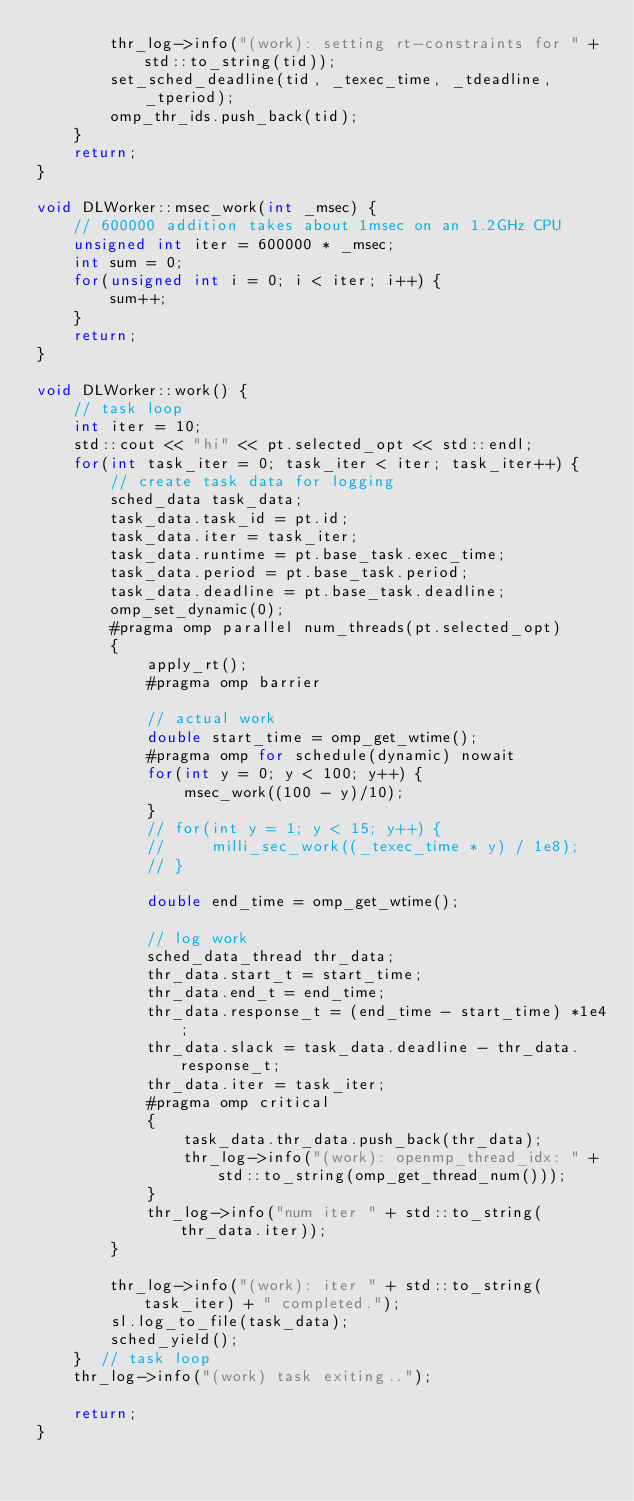Convert code to text. <code><loc_0><loc_0><loc_500><loc_500><_C++_>        thr_log->info("(work): setting rt-constraints for " + std::to_string(tid));
        set_sched_deadline(tid, _texec_time, _tdeadline, _tperiod);
        omp_thr_ids.push_back(tid);
    }
    return;
}

void DLWorker::msec_work(int _msec) {
    // 600000 addition takes about 1msec on an 1.2GHz CPU
    unsigned int iter = 600000 * _msec;
    int sum = 0;
    for(unsigned int i = 0; i < iter; i++) {
        sum++;
    }
    return;
}

void DLWorker::work() {
    // task loop
    int iter = 10;
    std::cout << "hi" << pt.selected_opt << std::endl;
    for(int task_iter = 0; task_iter < iter; task_iter++) {
        // create task data for logging
        sched_data task_data;
        task_data.task_id = pt.id;
        task_data.iter = task_iter;
        task_data.runtime = pt.base_task.exec_time;
        task_data.period = pt.base_task.period;
        task_data.deadline = pt.base_task.deadline;
        omp_set_dynamic(0);
        #pragma omp parallel num_threads(pt.selected_opt)
        {
            apply_rt();
            #pragma omp barrier

            // actual work
            double start_time = omp_get_wtime();
            #pragma omp for schedule(dynamic) nowait
            for(int y = 0; y < 100; y++) {
                msec_work((100 - y)/10);
            }
            // for(int y = 1; y < 15; y++) {
            //     milli_sec_work((_texec_time * y) / 1e8);
            // }
            
            double end_time = omp_get_wtime();

            // log work
            sched_data_thread thr_data;
            thr_data.start_t = start_time;
            thr_data.end_t = end_time;
            thr_data.response_t = (end_time - start_time) *1e4;
            thr_data.slack = task_data.deadline - thr_data.response_t;
            thr_data.iter = task_iter;
            #pragma omp critical
            {
                task_data.thr_data.push_back(thr_data);
                thr_log->info("(work): openmp_thread_idx: " + std::to_string(omp_get_thread_num()));
            }
            thr_log->info("num iter " + std::to_string(thr_data.iter));
        }

        thr_log->info("(work): iter " + std::to_string(task_iter) + " completed.");
        sl.log_to_file(task_data);
        sched_yield();
    }  // task loop
    thr_log->info("(work) task exiting..");

    return;
}
</code> 